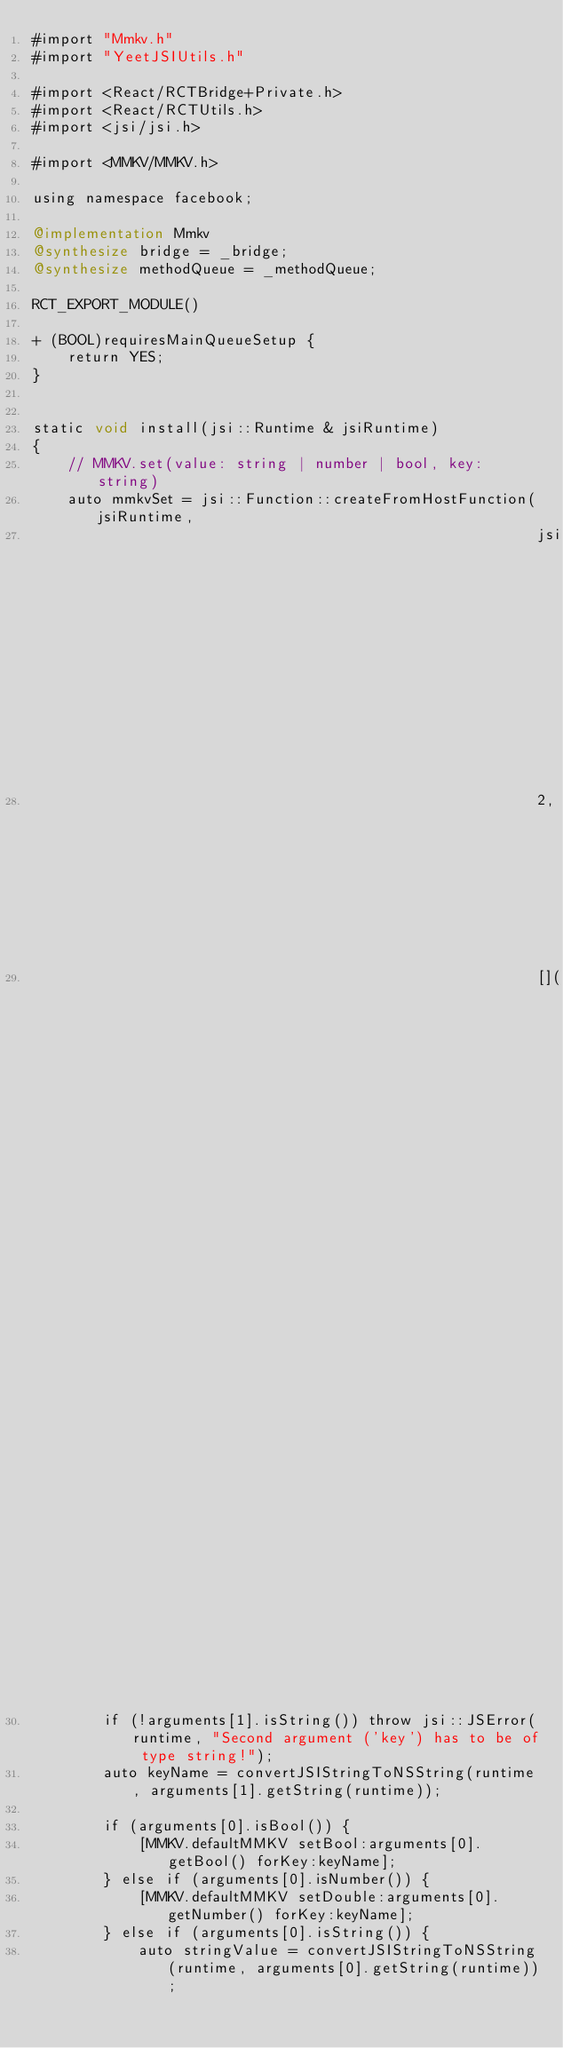Convert code to text. <code><loc_0><loc_0><loc_500><loc_500><_ObjectiveC_>#import "Mmkv.h"
#import "YeetJSIUtils.h"

#import <React/RCTBridge+Private.h>
#import <React/RCTUtils.h>
#import <jsi/jsi.h>

#import <MMKV/MMKV.h>

using namespace facebook;

@implementation Mmkv
@synthesize bridge = _bridge;
@synthesize methodQueue = _methodQueue;

RCT_EXPORT_MODULE()

+ (BOOL)requiresMainQueueSetup {
    return YES;
}


static void install(jsi::Runtime & jsiRuntime)
{
    // MMKV.set(value: string | number | bool, key: string)
    auto mmkvSet = jsi::Function::createFromHostFunction(jsiRuntime,
                                                         jsi::PropNameID::forAscii(jsiRuntime, "mmkvSet"),
                                                         2,  // value, key
                                                         [](jsi::Runtime& runtime, const jsi::Value& thisValue, const jsi::Value* arguments, size_t count) -> jsi::Value {
        if (!arguments[1].isString()) throw jsi::JSError(runtime, "Second argument ('key') has to be of type string!");
        auto keyName = convertJSIStringToNSString(runtime, arguments[1].getString(runtime));

        if (arguments[0].isBool()) {
            [MMKV.defaultMMKV setBool:arguments[0].getBool() forKey:keyName];
        } else if (arguments[0].isNumber()) {
            [MMKV.defaultMMKV setDouble:arguments[0].getNumber() forKey:keyName];
        } else if (arguments[0].isString()) {
            auto stringValue = convertJSIStringToNSString(runtime, arguments[0].getString(runtime));</code> 